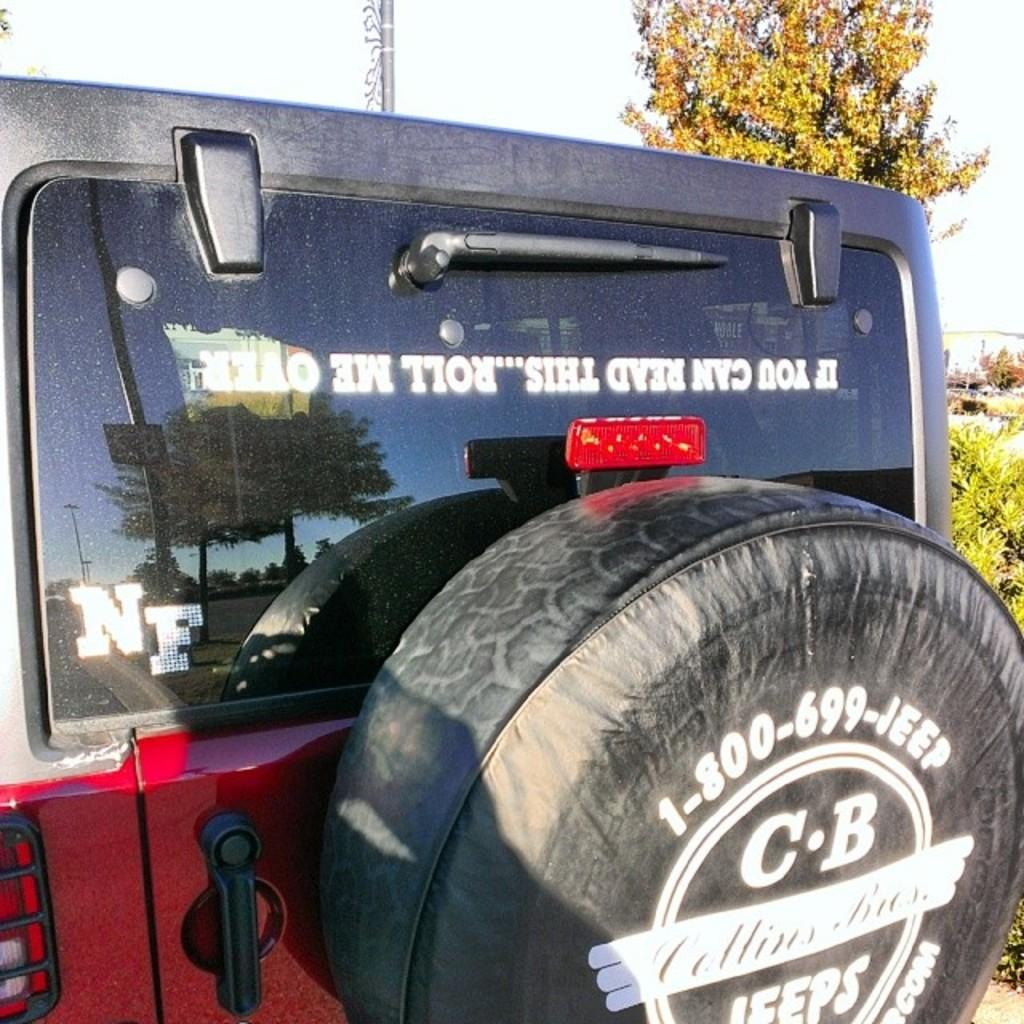What is the main subject in the center of the image? There is a car in the center of the image. What can be seen in the background of the image? There are trees and the sky visible in the background of the image. What sign is the car holding up in the image? There is no sign present in the image; it only features a car and the background. 